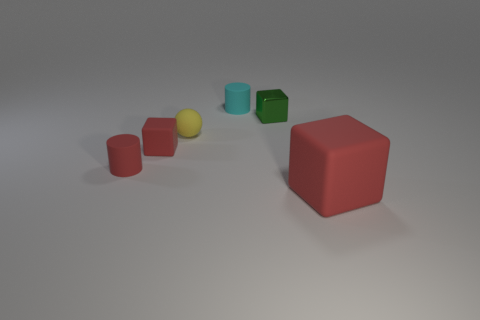What material is the cylinder that is the same color as the large matte cube?
Offer a terse response. Rubber. There is a small cylinder that is in front of the tiny matte cube; what number of shiny objects are to the left of it?
Offer a terse response. 0. There is a tiny cube that is right of the tiny yellow matte object; is it the same color as the cylinder in front of the tiny cyan object?
Your answer should be very brief. No. What is the material of the red block that is the same size as the shiny object?
Ensure brevity in your answer.  Rubber. What is the shape of the red rubber object that is behind the small red thing in front of the red rubber cube left of the big red cube?
Provide a short and direct response. Cube. What is the shape of the yellow object that is the same size as the cyan rubber object?
Give a very brief answer. Sphere. There is a matte block that is behind the matte cylinder that is in front of the small green metal cube; what number of tiny green cubes are in front of it?
Give a very brief answer. 0. Is the number of red rubber cubes that are on the left side of the small cyan matte thing greater than the number of yellow balls that are behind the green shiny object?
Ensure brevity in your answer.  Yes. How many rubber objects have the same shape as the small shiny object?
Your answer should be very brief. 2. What number of things are either red rubber objects left of the large matte block or red things on the right side of the cyan rubber cylinder?
Provide a succinct answer. 3. 